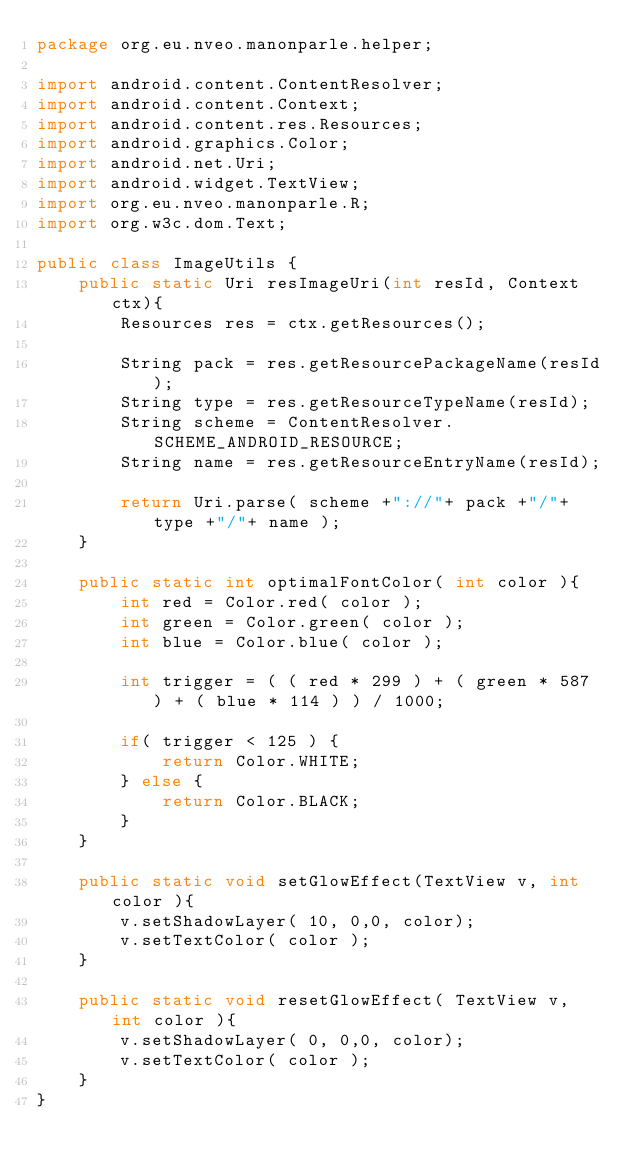Convert code to text. <code><loc_0><loc_0><loc_500><loc_500><_Java_>package org.eu.nveo.manonparle.helper;

import android.content.ContentResolver;
import android.content.Context;
import android.content.res.Resources;
import android.graphics.Color;
import android.net.Uri;
import android.widget.TextView;
import org.eu.nveo.manonparle.R;
import org.w3c.dom.Text;

public class ImageUtils {
    public static Uri resImageUri(int resId, Context ctx){
        Resources res = ctx.getResources();

        String pack = res.getResourcePackageName(resId);
        String type = res.getResourceTypeName(resId);
        String scheme = ContentResolver.SCHEME_ANDROID_RESOURCE;
        String name = res.getResourceEntryName(resId);

        return Uri.parse( scheme +"://"+ pack +"/"+ type +"/"+ name );
    }

    public static int optimalFontColor( int color ){
        int red = Color.red( color );
        int green = Color.green( color );
        int blue = Color.blue( color );

        int trigger = ( ( red * 299 ) + ( green * 587 ) + ( blue * 114 ) ) / 1000;

        if( trigger < 125 ) {
            return Color.WHITE;
        } else {
            return Color.BLACK;
        }
    }

    public static void setGlowEffect(TextView v, int color ){
        v.setShadowLayer( 10, 0,0, color);
        v.setTextColor( color );
    }

    public static void resetGlowEffect( TextView v, int color ){
        v.setShadowLayer( 0, 0,0, color);
        v.setTextColor( color );
    }
}
</code> 